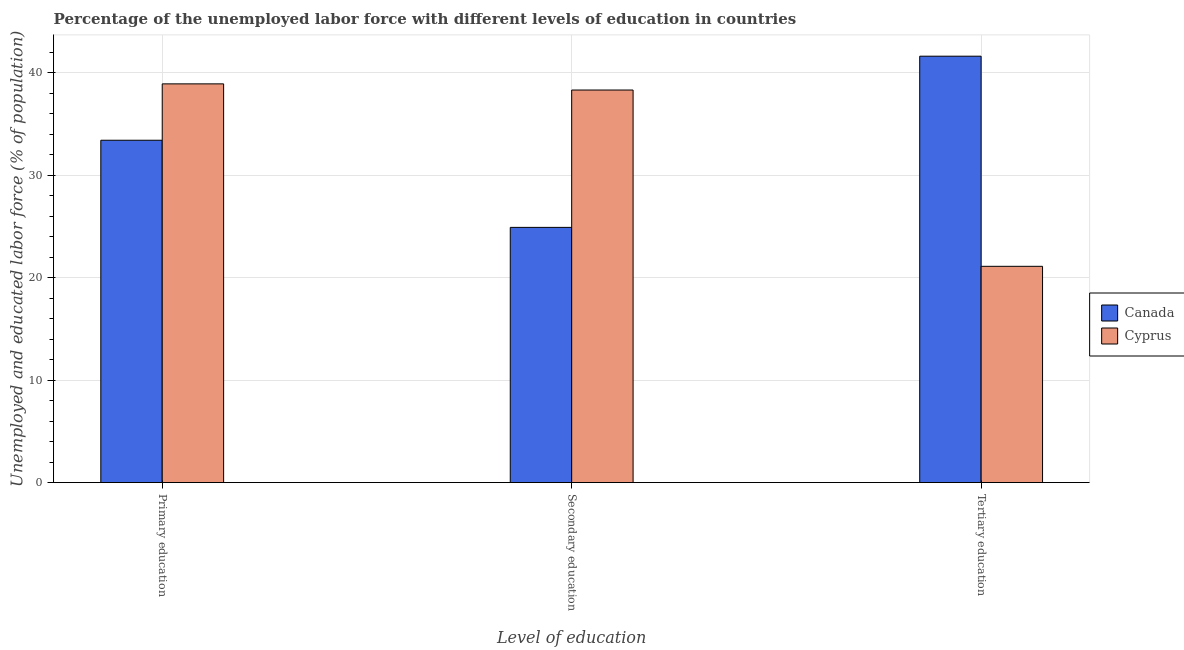How many groups of bars are there?
Give a very brief answer. 3. Are the number of bars per tick equal to the number of legend labels?
Offer a terse response. Yes. How many bars are there on the 1st tick from the right?
Offer a terse response. 2. What is the label of the 3rd group of bars from the left?
Offer a very short reply. Tertiary education. What is the percentage of labor force who received tertiary education in Cyprus?
Your answer should be compact. 21.1. Across all countries, what is the maximum percentage of labor force who received primary education?
Your answer should be very brief. 38.9. Across all countries, what is the minimum percentage of labor force who received secondary education?
Your answer should be compact. 24.9. In which country was the percentage of labor force who received primary education maximum?
Offer a terse response. Cyprus. In which country was the percentage of labor force who received tertiary education minimum?
Offer a very short reply. Cyprus. What is the total percentage of labor force who received secondary education in the graph?
Offer a terse response. 63.2. What is the difference between the percentage of labor force who received tertiary education in Canada and the percentage of labor force who received secondary education in Cyprus?
Provide a succinct answer. 3.3. What is the average percentage of labor force who received primary education per country?
Your response must be concise. 36.15. What is the difference between the percentage of labor force who received primary education and percentage of labor force who received tertiary education in Canada?
Make the answer very short. -8.2. In how many countries, is the percentage of labor force who received secondary education greater than 10 %?
Keep it short and to the point. 2. What is the ratio of the percentage of labor force who received tertiary education in Cyprus to that in Canada?
Give a very brief answer. 0.51. Is the percentage of labor force who received primary education in Cyprus less than that in Canada?
Ensure brevity in your answer.  No. What is the difference between the highest and the second highest percentage of labor force who received tertiary education?
Give a very brief answer. 20.5. What is the difference between the highest and the lowest percentage of labor force who received primary education?
Ensure brevity in your answer.  5.5. What does the 2nd bar from the left in Primary education represents?
Your response must be concise. Cyprus. What does the 1st bar from the right in Primary education represents?
Your response must be concise. Cyprus. How many bars are there?
Keep it short and to the point. 6. Are all the bars in the graph horizontal?
Make the answer very short. No. How many countries are there in the graph?
Your response must be concise. 2. Does the graph contain grids?
Keep it short and to the point. Yes. Where does the legend appear in the graph?
Your answer should be very brief. Center right. How many legend labels are there?
Offer a terse response. 2. How are the legend labels stacked?
Keep it short and to the point. Vertical. What is the title of the graph?
Give a very brief answer. Percentage of the unemployed labor force with different levels of education in countries. Does "Aruba" appear as one of the legend labels in the graph?
Provide a short and direct response. No. What is the label or title of the X-axis?
Keep it short and to the point. Level of education. What is the label or title of the Y-axis?
Provide a short and direct response. Unemployed and educated labor force (% of population). What is the Unemployed and educated labor force (% of population) in Canada in Primary education?
Make the answer very short. 33.4. What is the Unemployed and educated labor force (% of population) of Cyprus in Primary education?
Offer a very short reply. 38.9. What is the Unemployed and educated labor force (% of population) in Canada in Secondary education?
Offer a terse response. 24.9. What is the Unemployed and educated labor force (% of population) of Cyprus in Secondary education?
Your response must be concise. 38.3. What is the Unemployed and educated labor force (% of population) in Canada in Tertiary education?
Provide a short and direct response. 41.6. What is the Unemployed and educated labor force (% of population) in Cyprus in Tertiary education?
Give a very brief answer. 21.1. Across all Level of education, what is the maximum Unemployed and educated labor force (% of population) of Canada?
Keep it short and to the point. 41.6. Across all Level of education, what is the maximum Unemployed and educated labor force (% of population) of Cyprus?
Give a very brief answer. 38.9. Across all Level of education, what is the minimum Unemployed and educated labor force (% of population) in Canada?
Provide a short and direct response. 24.9. Across all Level of education, what is the minimum Unemployed and educated labor force (% of population) of Cyprus?
Offer a very short reply. 21.1. What is the total Unemployed and educated labor force (% of population) of Canada in the graph?
Offer a very short reply. 99.9. What is the total Unemployed and educated labor force (% of population) in Cyprus in the graph?
Offer a terse response. 98.3. What is the difference between the Unemployed and educated labor force (% of population) of Cyprus in Primary education and that in Secondary education?
Provide a succinct answer. 0.6. What is the difference between the Unemployed and educated labor force (% of population) of Cyprus in Primary education and that in Tertiary education?
Provide a succinct answer. 17.8. What is the difference between the Unemployed and educated labor force (% of population) of Canada in Secondary education and that in Tertiary education?
Keep it short and to the point. -16.7. What is the difference between the Unemployed and educated labor force (% of population) of Canada in Primary education and the Unemployed and educated labor force (% of population) of Cyprus in Secondary education?
Ensure brevity in your answer.  -4.9. What is the difference between the Unemployed and educated labor force (% of population) in Canada in Primary education and the Unemployed and educated labor force (% of population) in Cyprus in Tertiary education?
Make the answer very short. 12.3. What is the difference between the Unemployed and educated labor force (% of population) in Canada in Secondary education and the Unemployed and educated labor force (% of population) in Cyprus in Tertiary education?
Your response must be concise. 3.8. What is the average Unemployed and educated labor force (% of population) of Canada per Level of education?
Ensure brevity in your answer.  33.3. What is the average Unemployed and educated labor force (% of population) in Cyprus per Level of education?
Your response must be concise. 32.77. What is the difference between the Unemployed and educated labor force (% of population) in Canada and Unemployed and educated labor force (% of population) in Cyprus in Primary education?
Keep it short and to the point. -5.5. What is the difference between the Unemployed and educated labor force (% of population) in Canada and Unemployed and educated labor force (% of population) in Cyprus in Secondary education?
Your answer should be compact. -13.4. What is the difference between the Unemployed and educated labor force (% of population) of Canada and Unemployed and educated labor force (% of population) of Cyprus in Tertiary education?
Your answer should be very brief. 20.5. What is the ratio of the Unemployed and educated labor force (% of population) of Canada in Primary education to that in Secondary education?
Keep it short and to the point. 1.34. What is the ratio of the Unemployed and educated labor force (% of population) in Cyprus in Primary education to that in Secondary education?
Keep it short and to the point. 1.02. What is the ratio of the Unemployed and educated labor force (% of population) in Canada in Primary education to that in Tertiary education?
Provide a succinct answer. 0.8. What is the ratio of the Unemployed and educated labor force (% of population) in Cyprus in Primary education to that in Tertiary education?
Your response must be concise. 1.84. What is the ratio of the Unemployed and educated labor force (% of population) of Canada in Secondary education to that in Tertiary education?
Offer a very short reply. 0.6. What is the ratio of the Unemployed and educated labor force (% of population) in Cyprus in Secondary education to that in Tertiary education?
Offer a terse response. 1.82. What is the difference between the highest and the second highest Unemployed and educated labor force (% of population) in Canada?
Give a very brief answer. 8.2. What is the difference between the highest and the lowest Unemployed and educated labor force (% of population) in Cyprus?
Offer a very short reply. 17.8. 